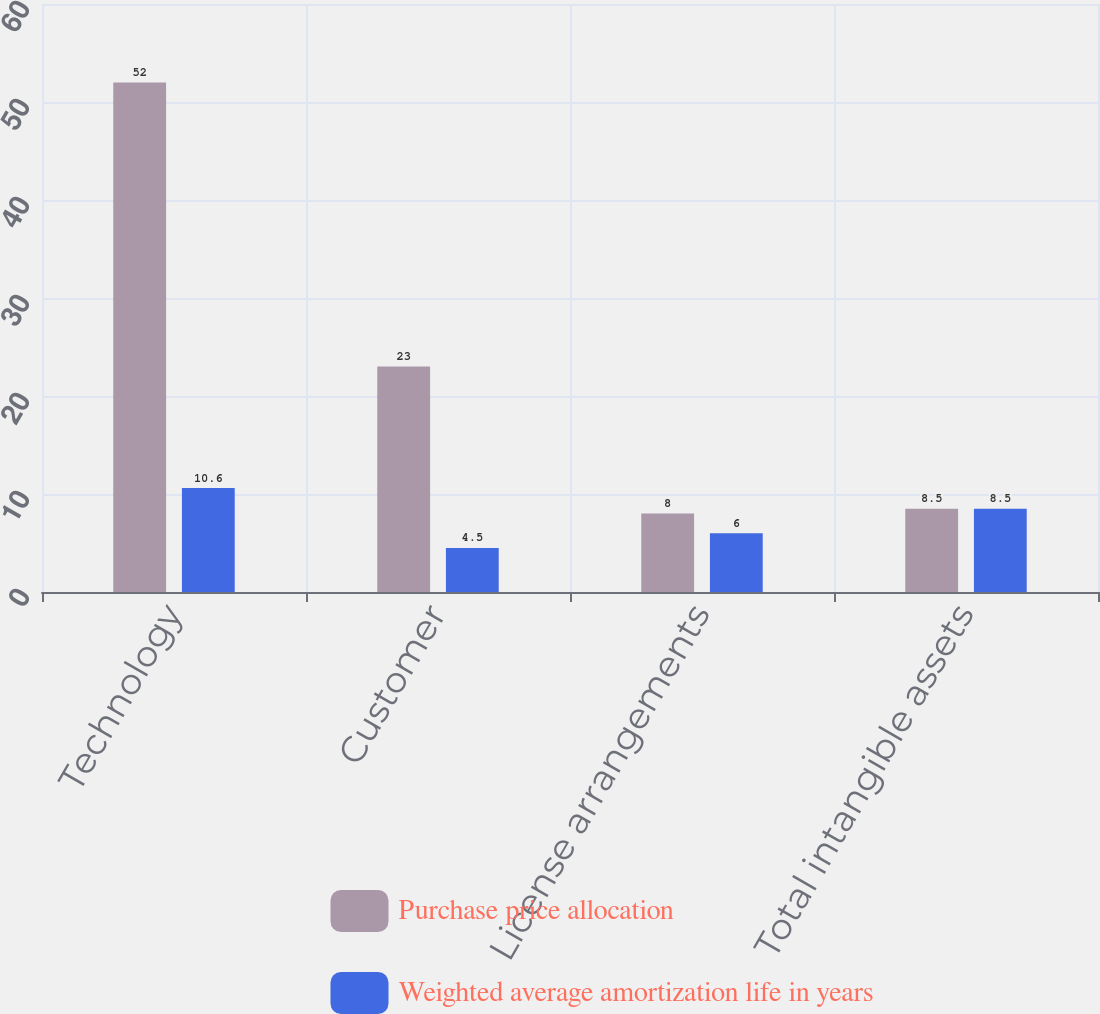<chart> <loc_0><loc_0><loc_500><loc_500><stacked_bar_chart><ecel><fcel>Technology<fcel>Customer<fcel>License arrangements<fcel>Total intangible assets<nl><fcel>Purchase price allocation<fcel>52<fcel>23<fcel>8<fcel>8.5<nl><fcel>Weighted average amortization life in years<fcel>10.6<fcel>4.5<fcel>6<fcel>8.5<nl></chart> 